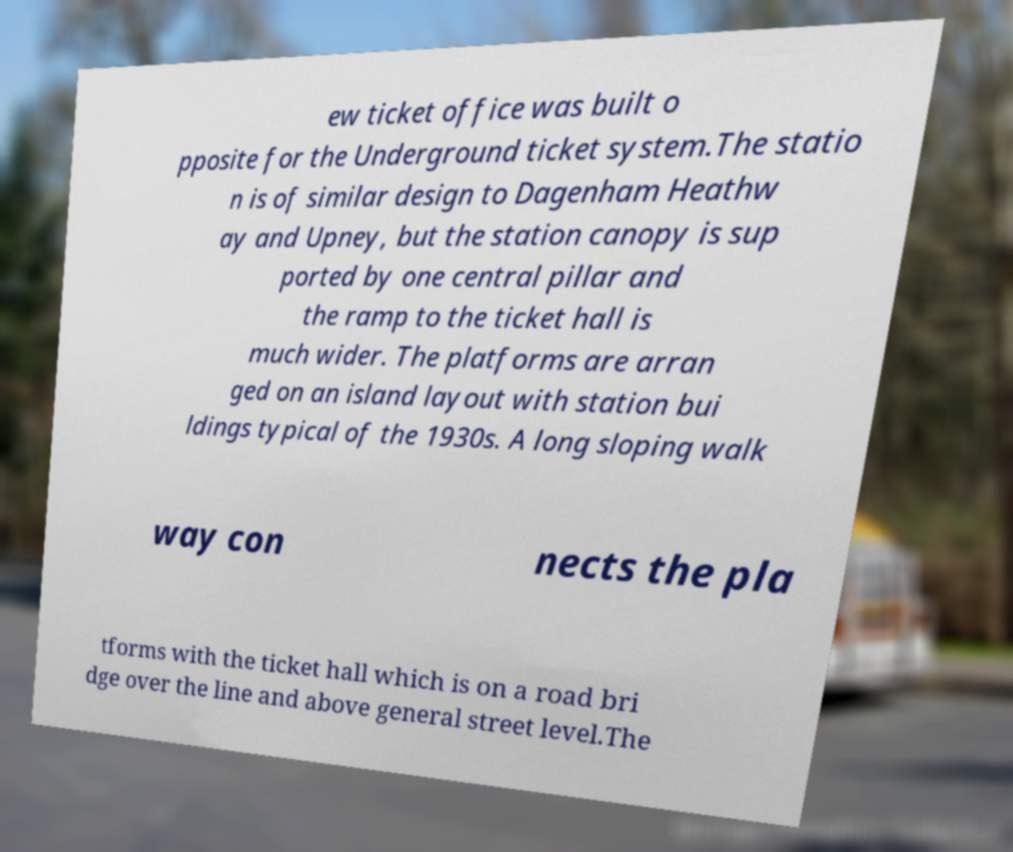Could you extract and type out the text from this image? ew ticket office was built o pposite for the Underground ticket system.The statio n is of similar design to Dagenham Heathw ay and Upney, but the station canopy is sup ported by one central pillar and the ramp to the ticket hall is much wider. The platforms are arran ged on an island layout with station bui ldings typical of the 1930s. A long sloping walk way con nects the pla tforms with the ticket hall which is on a road bri dge over the line and above general street level.The 